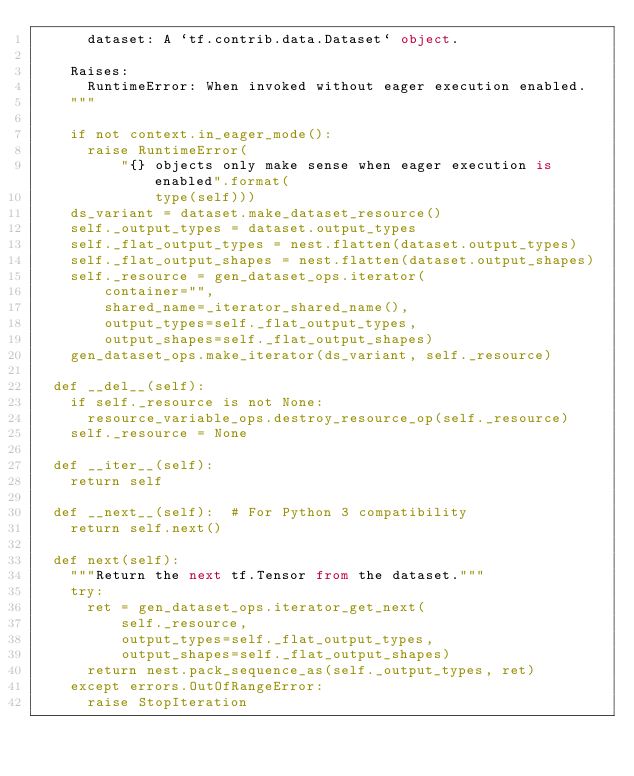<code> <loc_0><loc_0><loc_500><loc_500><_Python_>      dataset: A `tf.contrib.data.Dataset` object.

    Raises:
      RuntimeError: When invoked without eager execution enabled.
    """

    if not context.in_eager_mode():
      raise RuntimeError(
          "{} objects only make sense when eager execution is enabled".format(
              type(self)))
    ds_variant = dataset.make_dataset_resource()
    self._output_types = dataset.output_types
    self._flat_output_types = nest.flatten(dataset.output_types)
    self._flat_output_shapes = nest.flatten(dataset.output_shapes)
    self._resource = gen_dataset_ops.iterator(
        container="",
        shared_name=_iterator_shared_name(),
        output_types=self._flat_output_types,
        output_shapes=self._flat_output_shapes)
    gen_dataset_ops.make_iterator(ds_variant, self._resource)

  def __del__(self):
    if self._resource is not None:
      resource_variable_ops.destroy_resource_op(self._resource)
    self._resource = None

  def __iter__(self):
    return self

  def __next__(self):  # For Python 3 compatibility
    return self.next()

  def next(self):
    """Return the next tf.Tensor from the dataset."""
    try:
      ret = gen_dataset_ops.iterator_get_next(
          self._resource,
          output_types=self._flat_output_types,
          output_shapes=self._flat_output_shapes)
      return nest.pack_sequence_as(self._output_types, ret)
    except errors.OutOfRangeError:
      raise StopIteration
</code> 